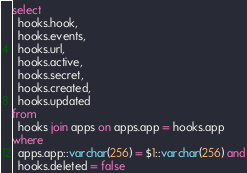<code> <loc_0><loc_0><loc_500><loc_500><_SQL_>select
  hooks.hook, 
  hooks.events, 
  hooks.url,
  hooks.active,
  hooks.secret,
  hooks.created, 
  hooks.updated
from
  hooks join apps on apps.app = hooks.app
where
  apps.app::varchar(256) = $1::varchar(256) and
  hooks.deleted = false
</code> 